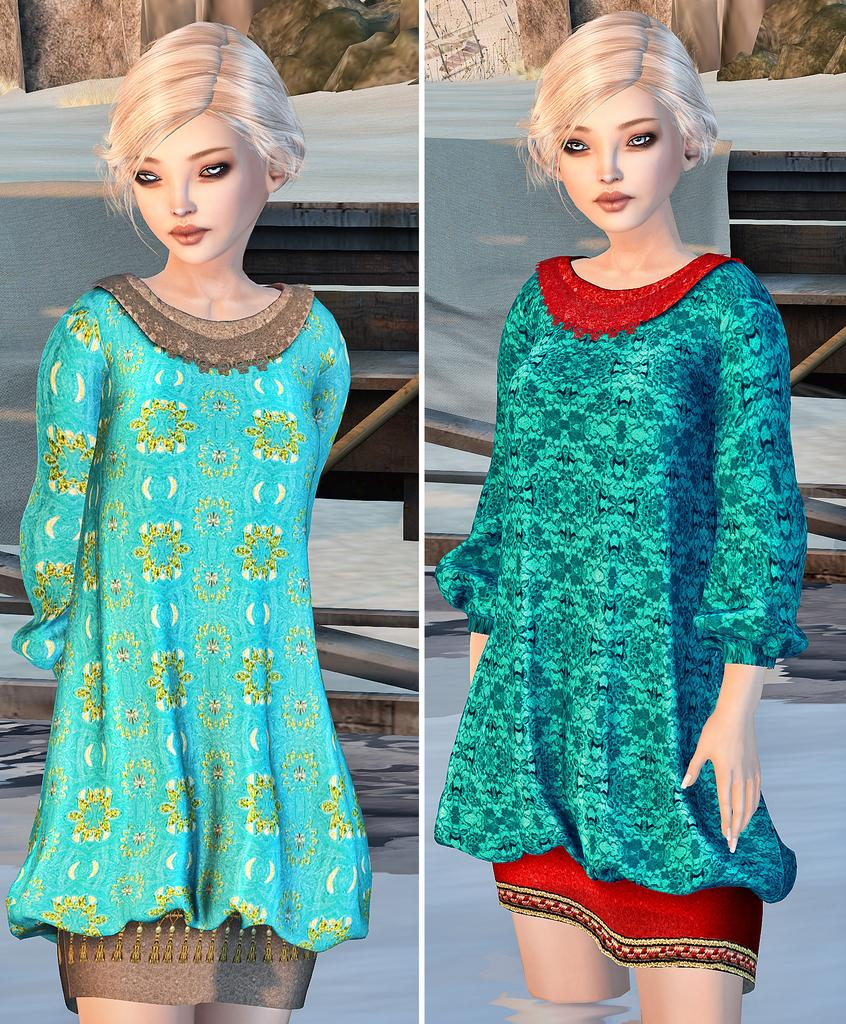What type of artwork is shown in the image? The image is a collage. What can be seen in the collage? There are depictions of persons in the water. What type of furniture is visible in the image? There are wooden tables visible in the image. What color is the gold toothbrush on the wooden table in the image? There is no gold toothbrush present in the image. 